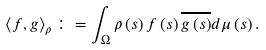Convert formula to latex. <formula><loc_0><loc_0><loc_500><loc_500>\left \langle f , g \right \rangle _ { \rho } \colon = \int _ { \Omega } \rho \left ( s \right ) f \left ( s \right ) \overline { g \left ( s \right ) } d \mu \left ( s \right ) .</formula> 